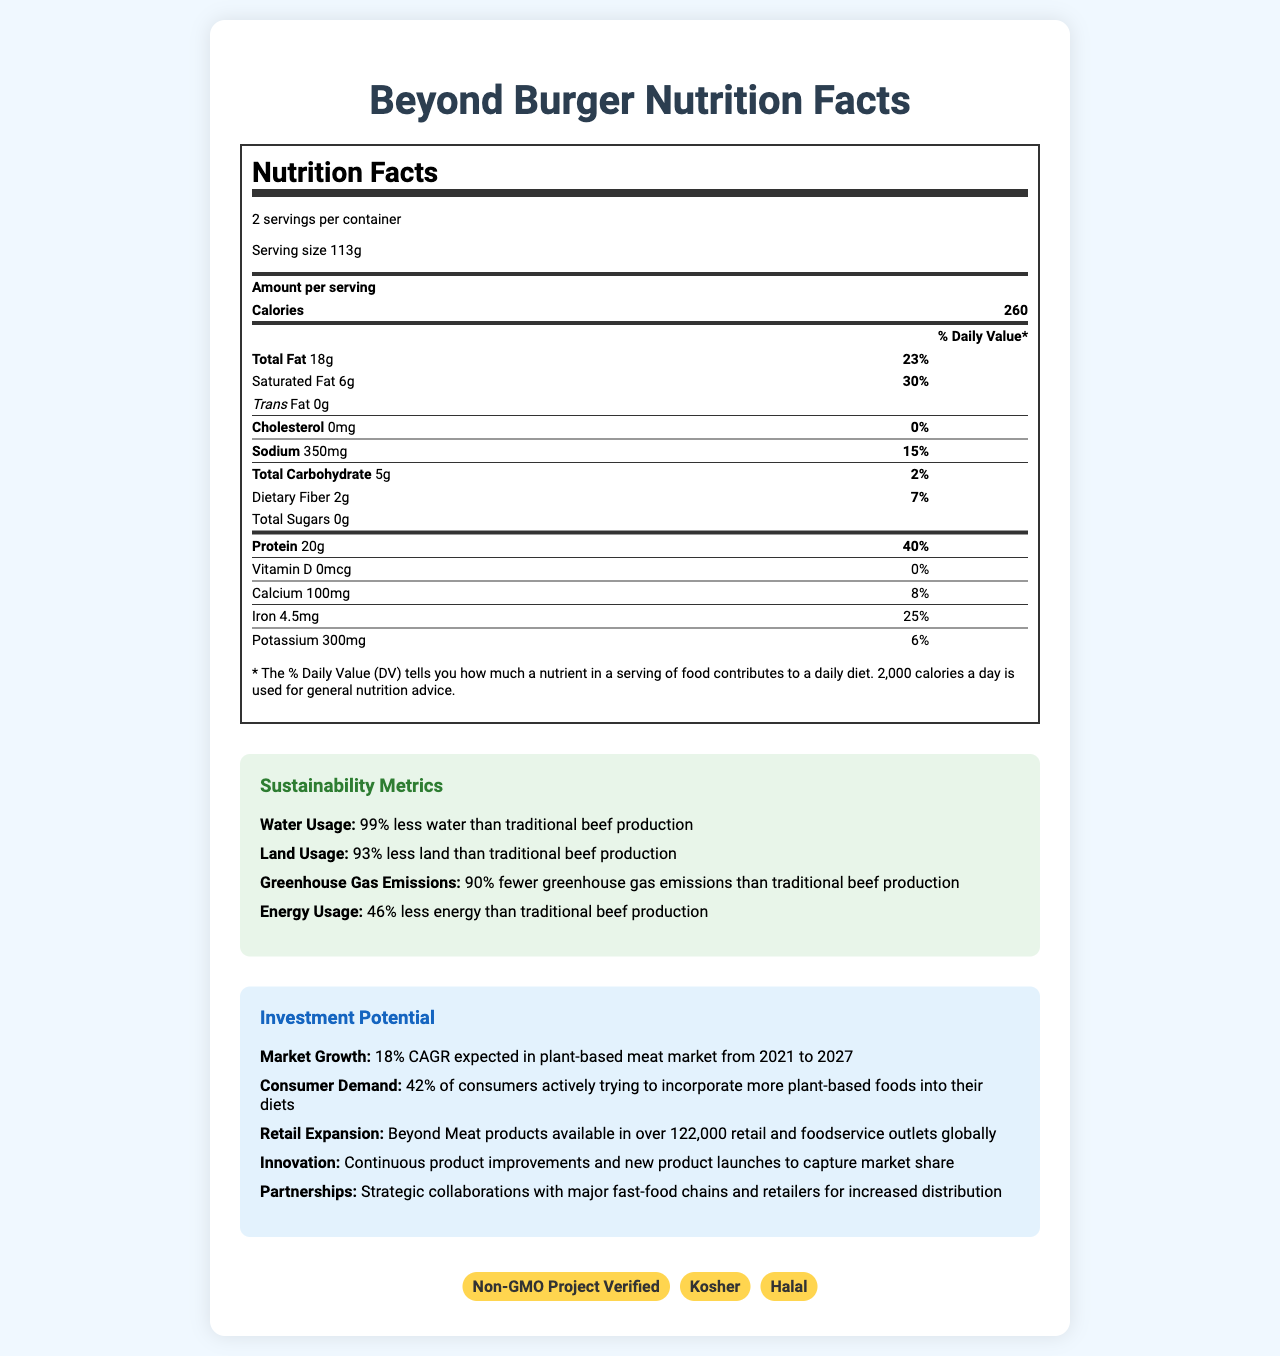What is the name of the product? The name of the product is shown at the top of the document.
Answer: Beyond Burger How many servings are in the container? The document states there are 2 servings per container.
Answer: 2 What is the serving size of the Beyond Burger? The document specifies the serving size as 113g.
Answer: 113g How many calories are in one serving of the Beyond Burger? The document lists the calories per serving as 260.
Answer: 260 What is the total fat content per serving? The document shows the total fat content as 18g per serving.
Answer: 18g Which of the following nutrients has the highest daily value percentage in the Beyond Burger? A. Calcium B. Protein C. Iron D. Dietary Fiber The daily value percentage for protein is 40%, which is higher than that of calcium (8%), iron (25%), and dietary fiber (7%).
Answer: B. Protein Which ingredient in the Beyond Burger could be an allergen? A. Pea Protein B. Coconut Oil C. Apple Extract D. Vinegar The document lists coconut as an allergen.
Answer: B. Coconut Oil Does the Beyond Burger contain any cholesterol? The document states that the cholesterol content is 0mg.
Answer: No What is one key sustainability metric listed in the document? One of the sustainability metrics mentioned is that the Beyond Burger uses 99% less water than traditional beef production.
Answer: The Beyond Burger uses 99% less water than traditional beef production. What certifications does the Beyond Burger have? The certifications listed in the document are Non-GMO Project Verified, Kosher, and Halal.
Answer: Non-GMO Project Verified, Kosher, Halal How much iron is in one serving of the Beyond Burger? The document specifies that there are 4.5mg of iron per serving.
Answer: 4.5mg What is the expected market growth for the plant-based meat market from 2021 to 2027? A. 10% B. 15% C. 18% D. 25% The document states that the market growth is expected to be 18% CAGR from 2021 to 2027.
Answer: C. 18% Do Beyond Burger products have any non-GMO certifications? The document lists Non-GMO Project Verified as one of the certifications.
Answer: Yes Summarize the main idea of the document. The document contains various sections including nutritional information, sustainability metrics, investment potential, and certifications for the Beyond Burger, aimed at showcasing its value and potential as a plant-based meat alternative.
Answer: The document provides detailed nutrition facts, sustainability metrics, and investment potential for the Beyond Burger, highlighting its nutritional value, environmental benefits, market growth, and certifications. What is the average daily percentage value for carbohydrates in the Beyond Burger? The information provided shows only the daily value for total carbohydrate content (2%) but not the breakdown needed to calculate an average.
Answer: Cannot be determined In what type of outlets are Beyond Meat products available globally? The document mentions that Beyond Meat products are available in over 122,000 retail and foodservice outlets globally.
Answer: Over 122,000 retail and foodservice outlets 